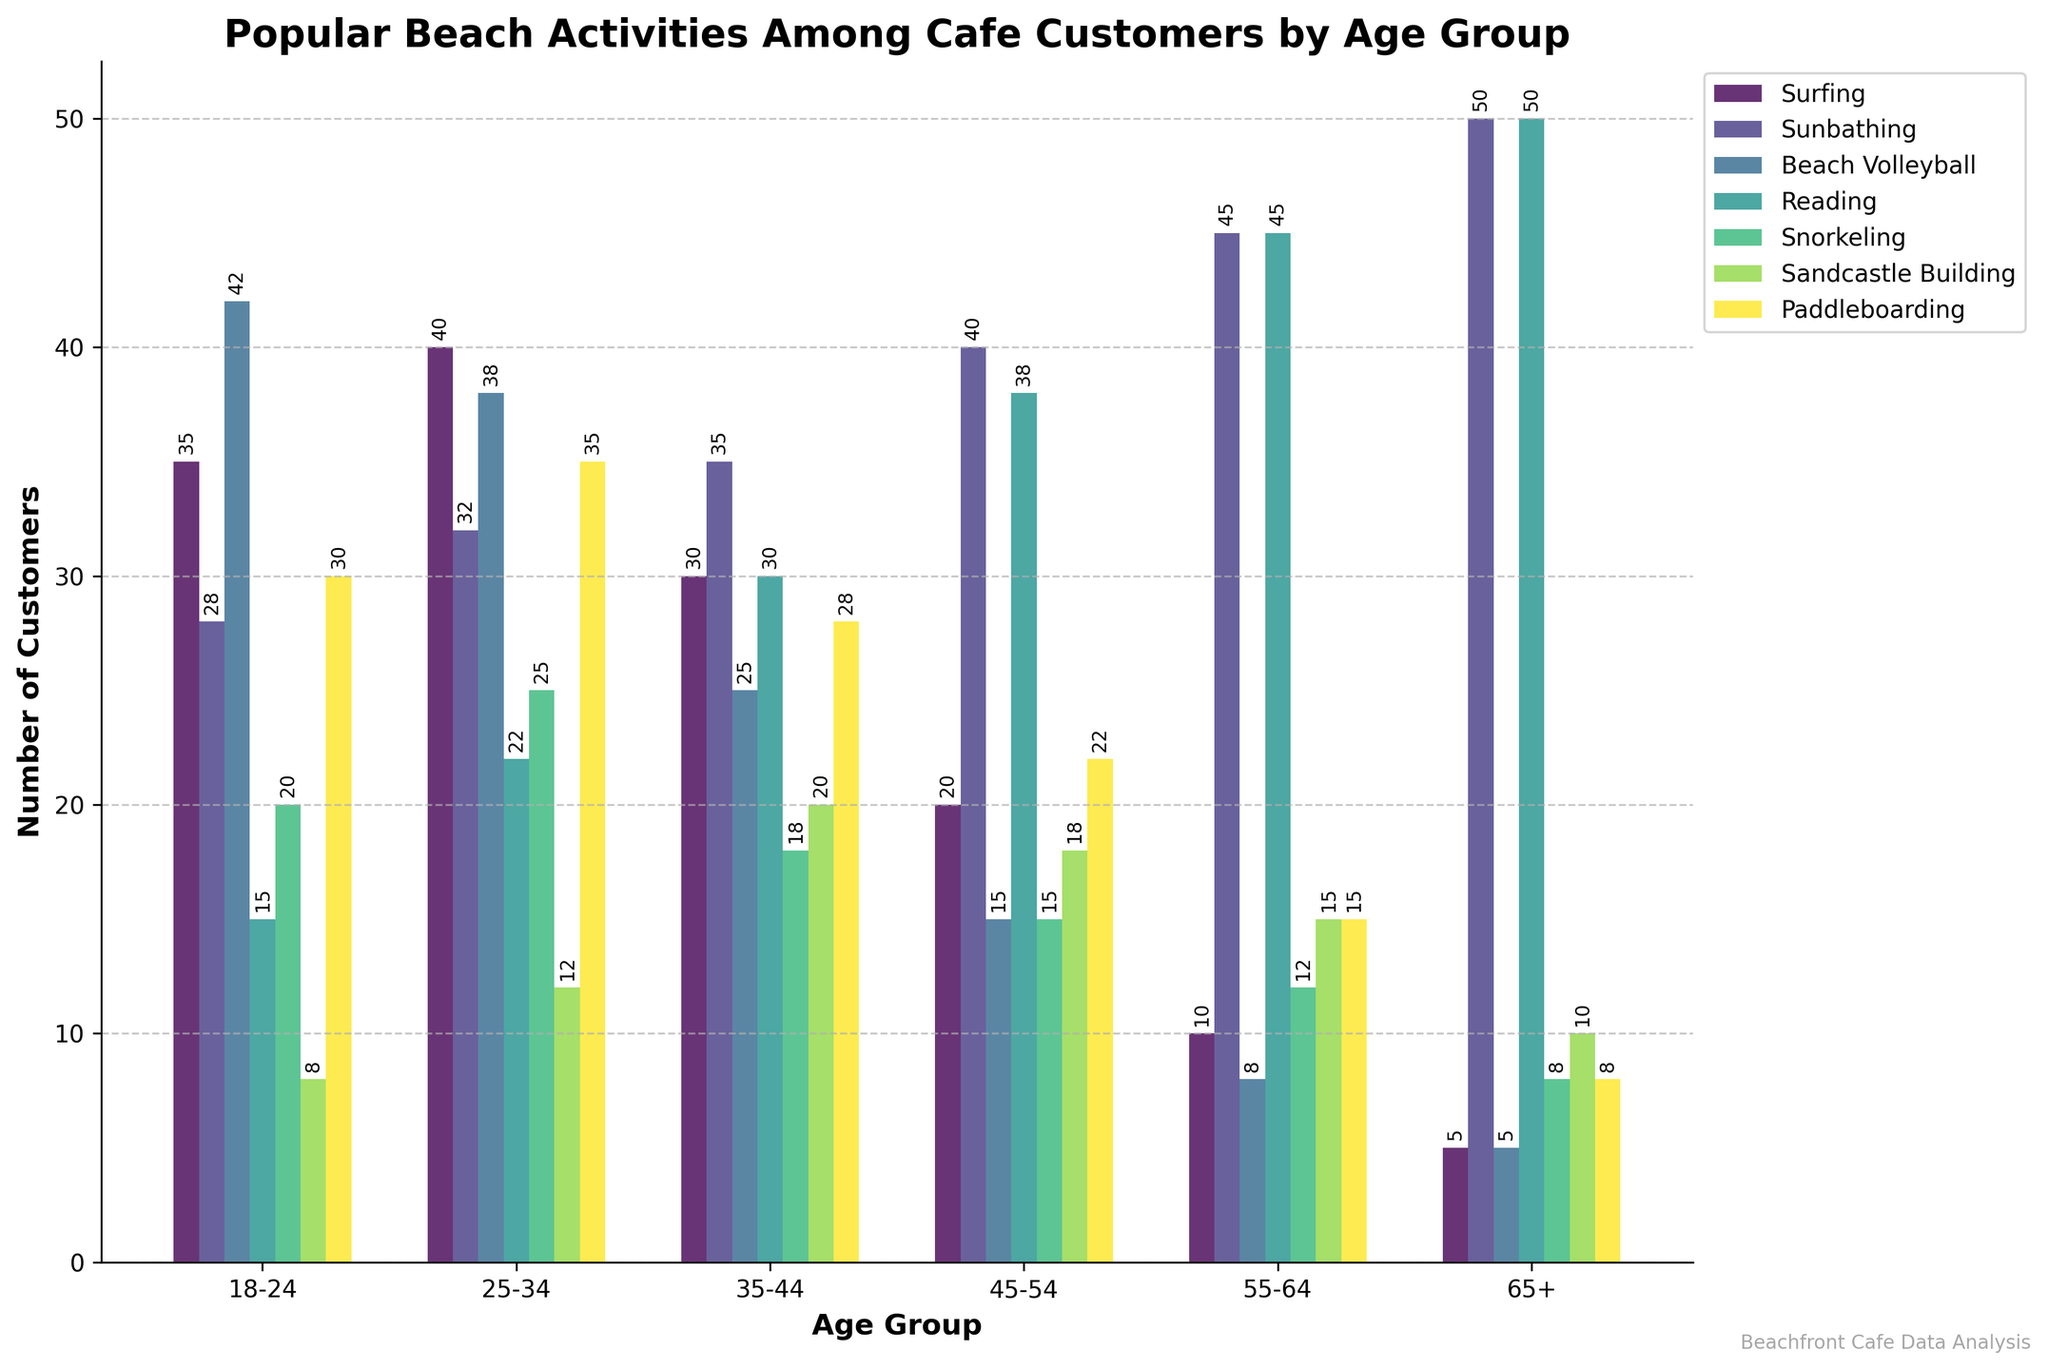Which age group has the highest number of customers participating in Sunbathing? Look at the height of the bars representing Sunbathing (colored consistently) for each age group. The 65+ age group has the tallest bar.
Answer: 65+ For the age group 45-54, how many more customers prefer Reading over Snorkeling? Check the bar heights for Reading and Snorkeling in the 45-54 age group. Reading has 38 customers, while Snorkeling has 15 customers. The difference is 38 - 15.
Answer: 23 Which activity is most popular among customers aged 18-24? By comparing the heights of the bars within the 18-24 age group, Beach Volleyball has the tallest bar.
Answer: Beach Volleyball How does the number of customers engaged in Sandcastle Building change from the 25-34 age group to the 35-44 age group? Look at the heights of the Sandcastle Building bars for the 25-34 and 35-44 age groups. The values are 12 and 20, respectively. Calculate the difference 20 - 12.
Answer: Increase by 8 What is the average number of customers participating in Surfing across all age groups? Sum the numbers for Surfing across all age groups (35+40+30+20+10+5=140) and divide by the number of age groups (6).
Answer: 23.33 Compare the popularity of Paddleboarding between the youngest (18-24) and the oldest (65+) age groups. Refer to the heights of the Paddleboarding bars. The values are 30 for the 18-24 age group and 8 for the 65+ age group.
Answer: Younger group has 22 more customers Which activity has the least number of customers in the 55-64 age group? Identify the shortest bar within the 55-64 age group. The shortest bar represents Beach Volleyball with 8 customers.
Answer: Beach Volleyball Between Sunbathing and Reading, which activity gains more popularity as age increases? Track the progression of the heights of the Sunbathing and Reading bars across age groups. Sunbathing consistently increases more than Reading as age increases.
Answer: Sunbathing How many total customers across all age groups participate in Snorkeling? Sum the numbers of customers for Snorkeling in all age groups (20+25+18+15+12+8=98).
Answer: 98 In the 35-44 age group, is Surfing more popular than Sunbathing? Compare the heights of the Surfing and Sunbathing bars for the 35-44 age group. Surfing has 30 customers while Sunbathing has 35.
Answer: No 